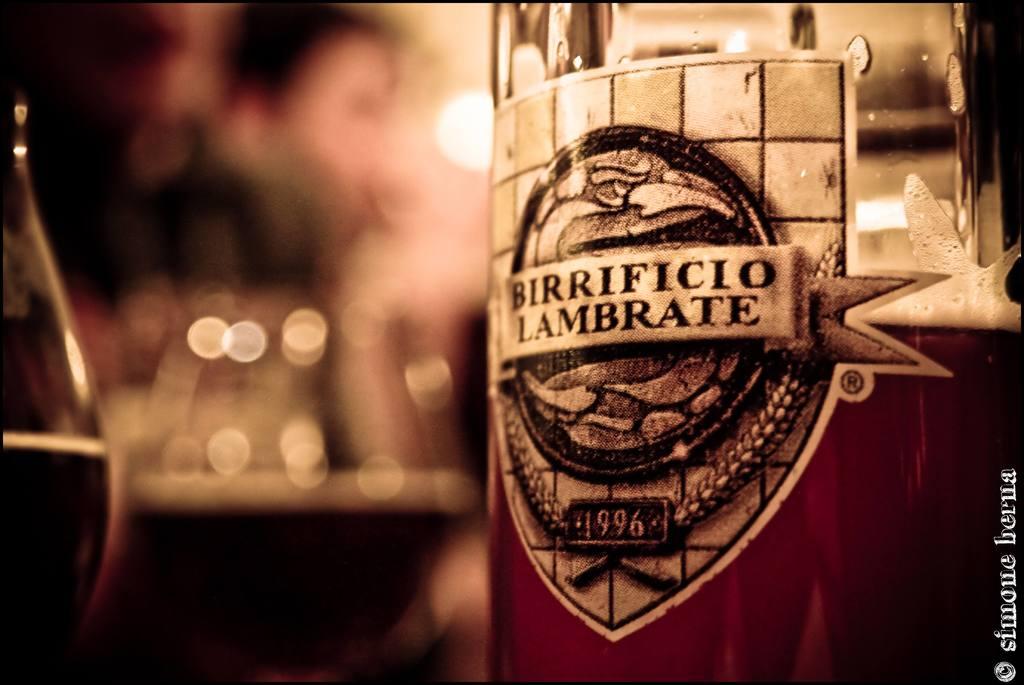What is the name of the beverage?
Offer a very short reply. Birrificio lambrate. 